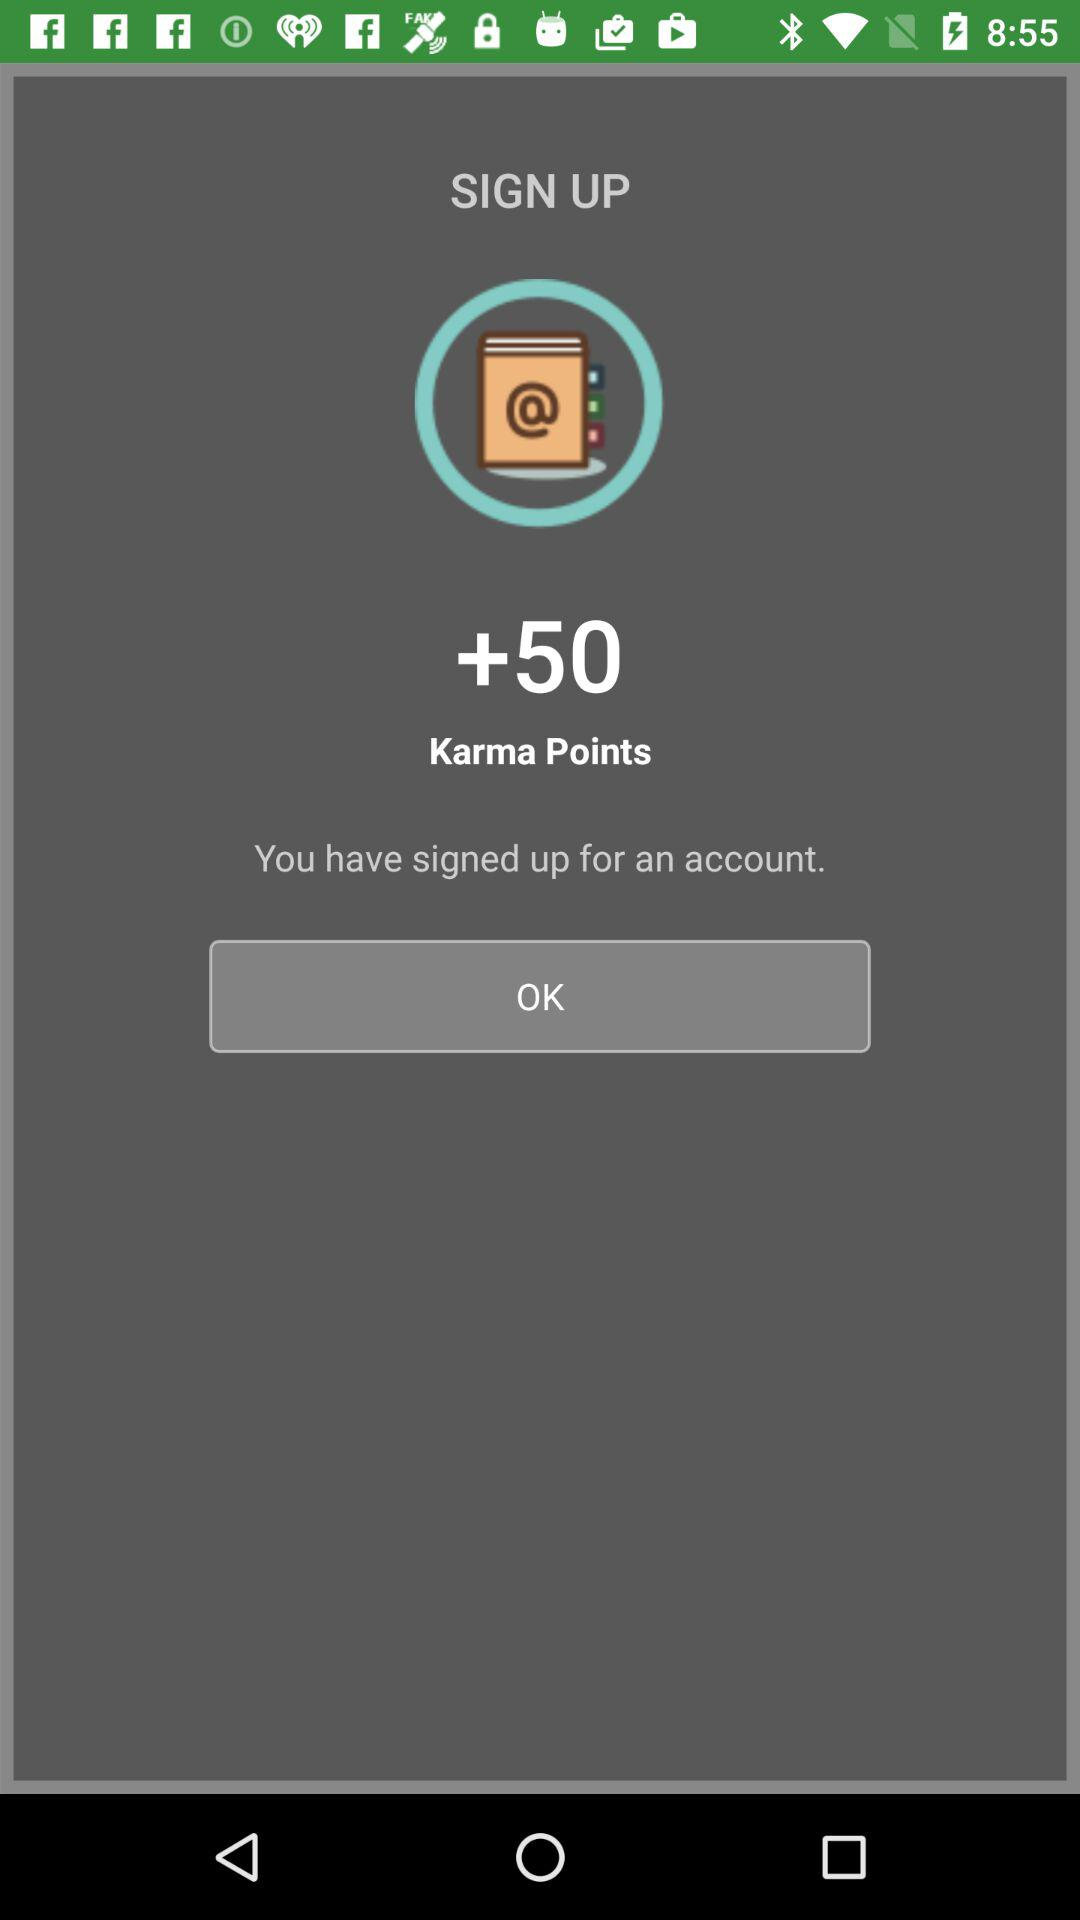How many Karma Points are there? There are 50 Karma Points. 